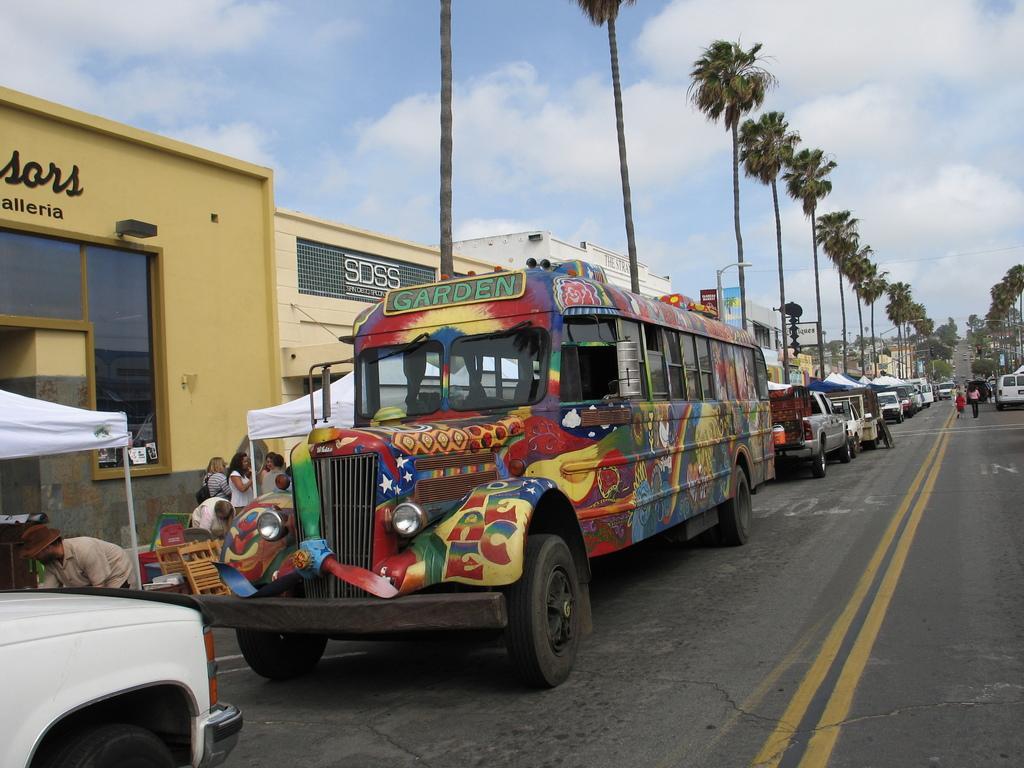How would you summarize this image in a sentence or two? In the center of the image we can see a few vehicles on the road. In the background, we can see the sky, clouds, buildings, trees, tents, few people and a few other objects. 